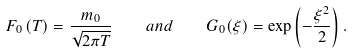Convert formula to latex. <formula><loc_0><loc_0><loc_500><loc_500>F _ { 0 } \left ( T \right ) = \frac { m _ { 0 } } { \sqrt { 2 \pi T } } \quad a n d \quad G _ { 0 } ( \xi ) = \exp \left ( - \frac { \xi ^ { 2 } } 2 \right ) .</formula> 